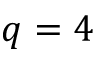<formula> <loc_0><loc_0><loc_500><loc_500>q = 4</formula> 